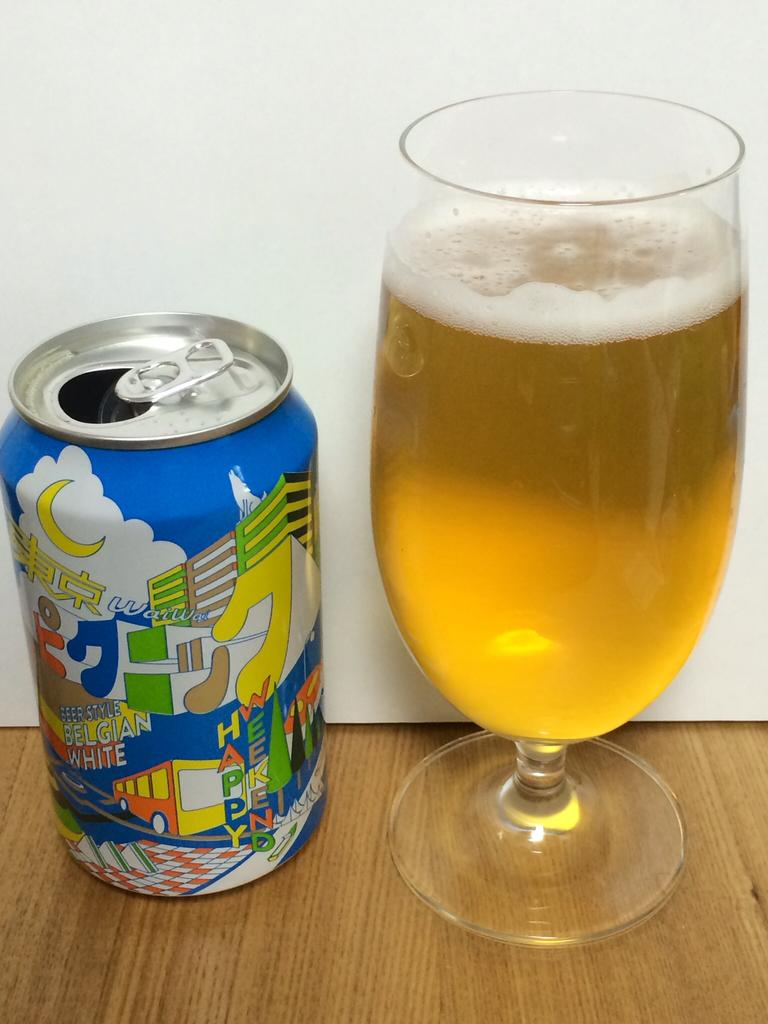<image>
Give a short and clear explanation of the subsequent image. A can of Belgian White and a glass with beer in it are on a wooden table top. 